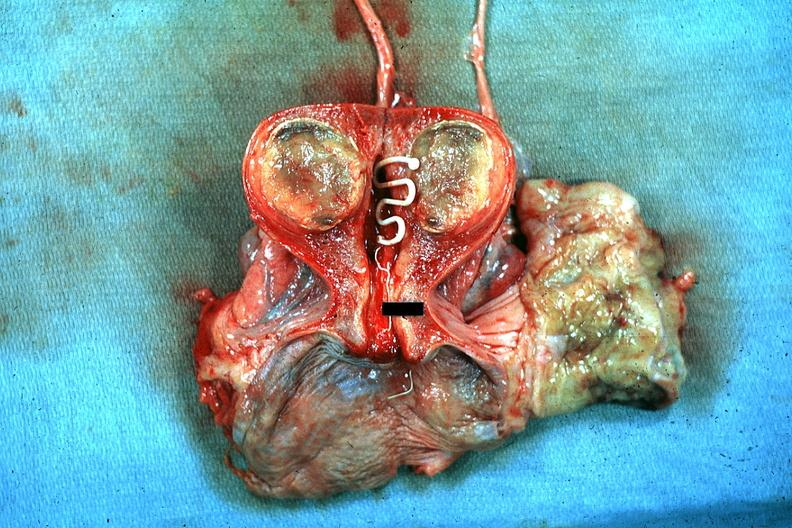how does this image show excellent plastic coil?
Answer the question using a single word or phrase. With deep red endometrium and degenerating mural myoma 